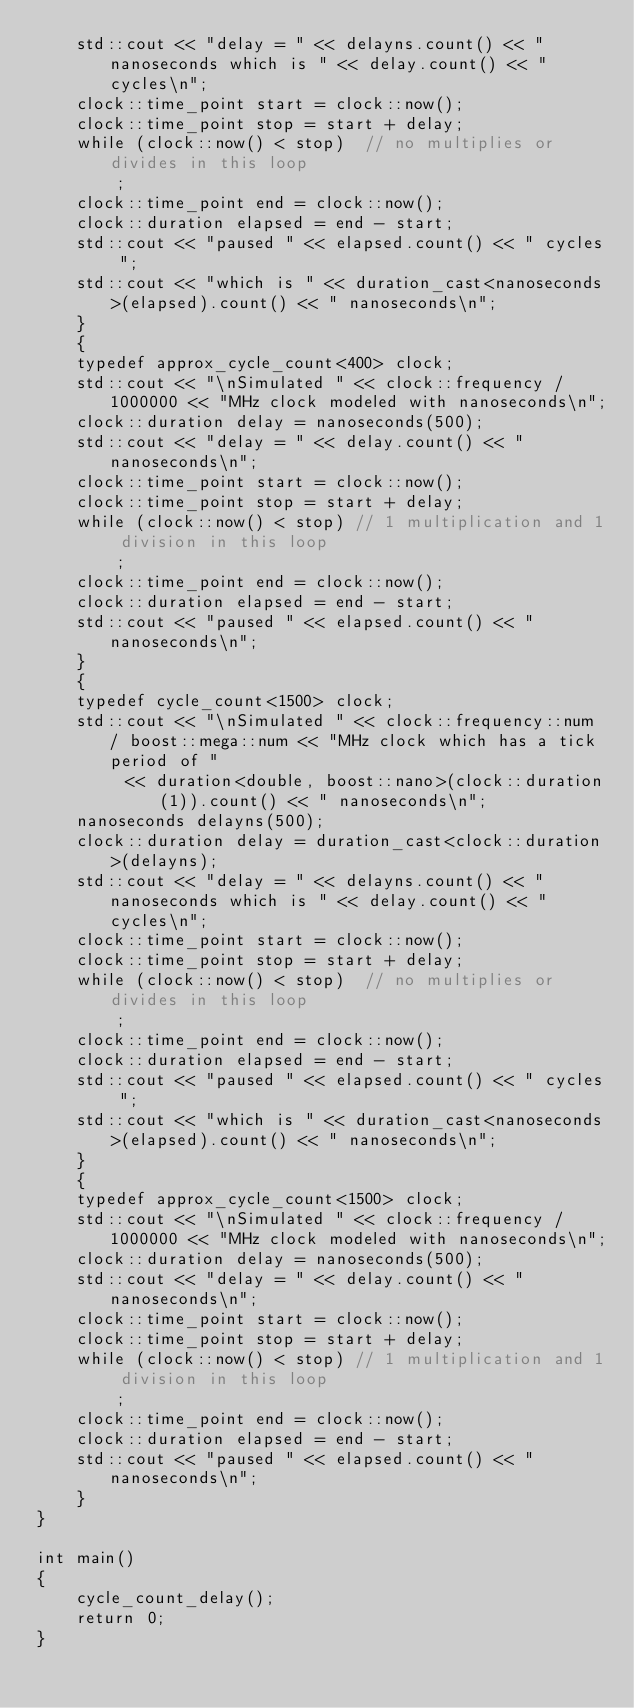<code> <loc_0><loc_0><loc_500><loc_500><_C++_>    std::cout << "delay = " << delayns.count() << " nanoseconds which is " << delay.count() << " cycles\n";
    clock::time_point start = clock::now();
    clock::time_point stop = start + delay;
    while (clock::now() < stop)  // no multiplies or divides in this loop
        ;
    clock::time_point end = clock::now();
    clock::duration elapsed = end - start;
    std::cout << "paused " << elapsed.count() << " cycles ";
    std::cout << "which is " << duration_cast<nanoseconds>(elapsed).count() << " nanoseconds\n";
    }
    {
    typedef approx_cycle_count<400> clock;
    std::cout << "\nSimulated " << clock::frequency / 1000000 << "MHz clock modeled with nanoseconds\n";
    clock::duration delay = nanoseconds(500);
    std::cout << "delay = " << delay.count() << " nanoseconds\n";
    clock::time_point start = clock::now();
    clock::time_point stop = start + delay;
    while (clock::now() < stop) // 1 multiplication and 1 division in this loop
        ;
    clock::time_point end = clock::now();
    clock::duration elapsed = end - start;
    std::cout << "paused " << elapsed.count() << " nanoseconds\n";
    }
    {
    typedef cycle_count<1500> clock;
    std::cout << "\nSimulated " << clock::frequency::num / boost::mega::num << "MHz clock which has a tick period of "
         << duration<double, boost::nano>(clock::duration(1)).count() << " nanoseconds\n";
    nanoseconds delayns(500);
    clock::duration delay = duration_cast<clock::duration>(delayns);
    std::cout << "delay = " << delayns.count() << " nanoseconds which is " << delay.count() << " cycles\n";
    clock::time_point start = clock::now();
    clock::time_point stop = start + delay;
    while (clock::now() < stop)  // no multiplies or divides in this loop
        ;
    clock::time_point end = clock::now();
    clock::duration elapsed = end - start;
    std::cout << "paused " << elapsed.count() << " cycles ";
    std::cout << "which is " << duration_cast<nanoseconds>(elapsed).count() << " nanoseconds\n";
    }
    {
    typedef approx_cycle_count<1500> clock;
    std::cout << "\nSimulated " << clock::frequency / 1000000 << "MHz clock modeled with nanoseconds\n";
    clock::duration delay = nanoseconds(500);
    std::cout << "delay = " << delay.count() << " nanoseconds\n";
    clock::time_point start = clock::now();
    clock::time_point stop = start + delay;
    while (clock::now() < stop) // 1 multiplication and 1 division in this loop
        ;
    clock::time_point end = clock::now();
    clock::duration elapsed = end - start;
    std::cout << "paused " << elapsed.count() << " nanoseconds\n";
    }
}

int main()
{
    cycle_count_delay();
    return 0;
}

</code> 